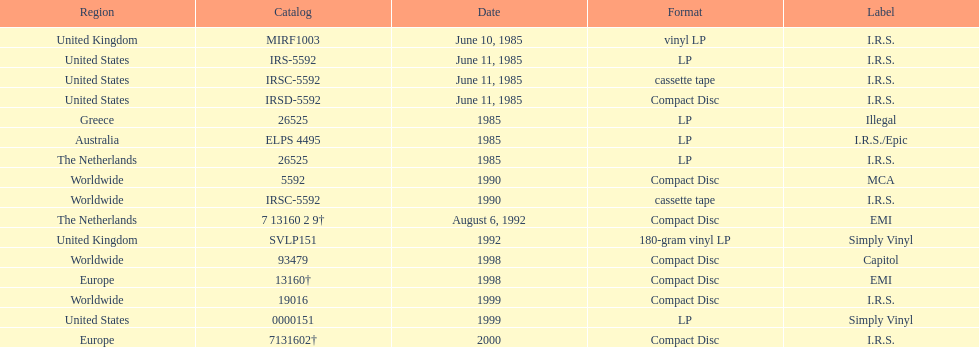Which region was the last to release? Europe. 